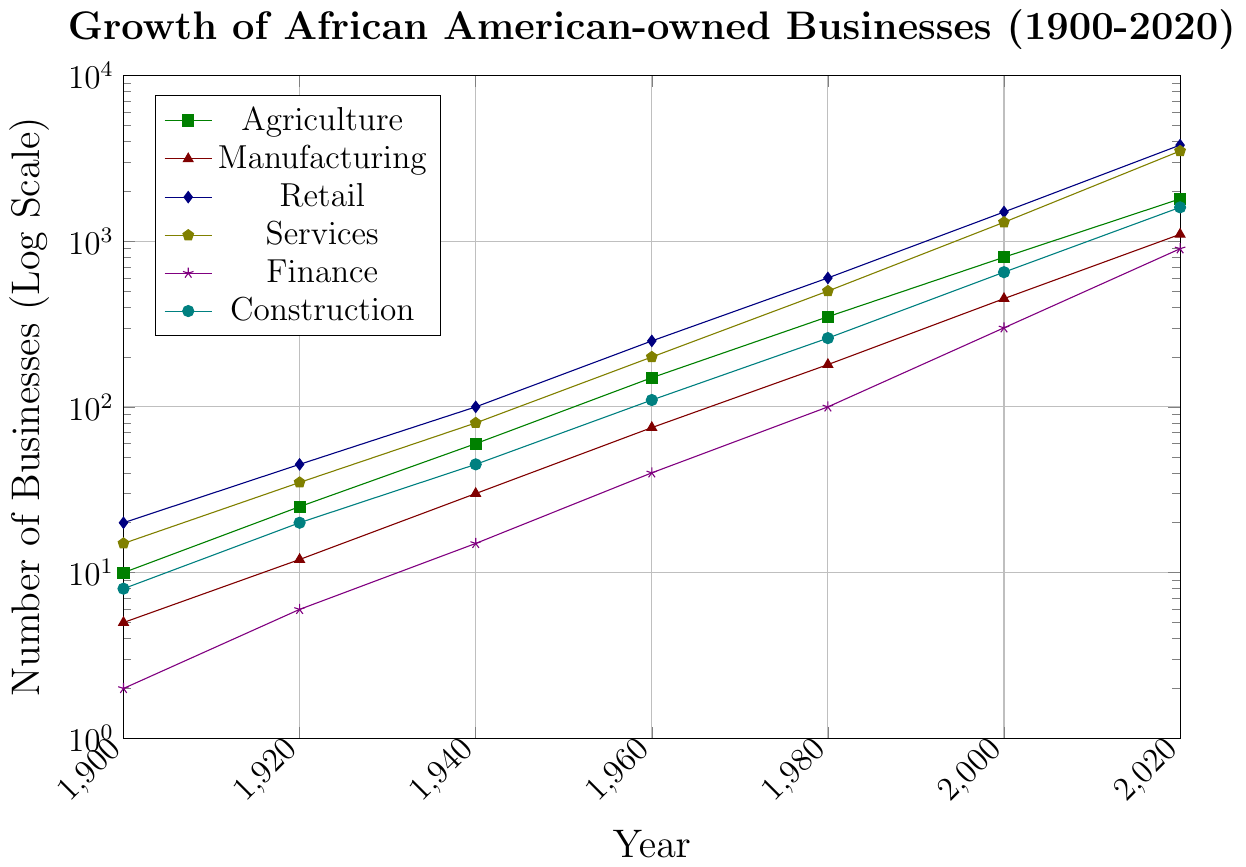What is the overall trend in the number of African American-owned retail businesses from 1900 to 2020? To assess the trend, examine the data points for retail businesses from 1900 (20) through 2020 (3800). All values show a consistent increase over time.
Answer: Increasing Which industry saw the highest number of businesses owned by African Americans in 1940? Compare the data points for each industry in 1940: Agriculture (60), Manufacturing (30), Retail (100), Services (80), Finance (15), and Construction (45). The highest value is in Retail with 100 businesses.
Answer: Retail By how much did the number of African American-owned services businesses increase from 1960 to 2020? The number of services businesses in 1960 is 200 and in 2020 is 3500. The increase is 3500 - 200 = 3300.
Answer: 3300 Which industry had the least growth in the number of African American-owned businesses from 1920 to 2020? Calculate the growth for each industry from 1920 to 2020: Agriculture (1800-25), Manufacturing (1100-12), Retail (3800-45), Services (3500-35), Finance (900-6), Construction (1600-20). Compare these differences, the growth for each is: Agriculture (1775), Manufacturing (1088), Retail (3755), Services (3465), Finance (894), and Construction (1580). The least growth is in Finance with 894.
Answer: Finance What is the ratio of the number of African American-owned retail businesses to manufacturing businesses in 1980? The number of retail businesses in 1980 is 600 and manufacturing businesses is 180. The ratio is 600 / 180 = 3.33.
Answer: 3.33 Which sector had the largest relative growth (as a percentage) from 1900 to 2020? To compute the relative growth for each sector, use the formula: \((\text{value in 2020} - \text{value in 1900}) / \text{value in 1900} \times 100%\). Calculate for each:
Agriculture: \((1800-10) / 10 \times 100\% = 17900\%\)
Manufacturing: \((1100-5) / 5 \times 100\% = 21800\%\)
Retail: \((3800-20) / 20 \times 100\% = 18900\%\)
Services: \((3500-15) / 15 \times 100\% = 23300\%\)
Finance: \((900-2) / 2 \times 100\% = 44900\%\)
Construction: \((1600-8) / 8 \times 100\% = 19900\%\)
The highest percentage growth is in Finance with 44900%.
Answer: Finance Which industry had an exponential growth pattern and at what year did it have a noticeable rapid increase? To determine exponential growth, look for data that shows rapid and accelerating increases over time. Most sectors exhibit this pattern, but focus on when the rapid increase becomes evident. A rapid rise for Retail is seen between 1960 (250) and 1980 (600).
Answer: Retail in 1980 